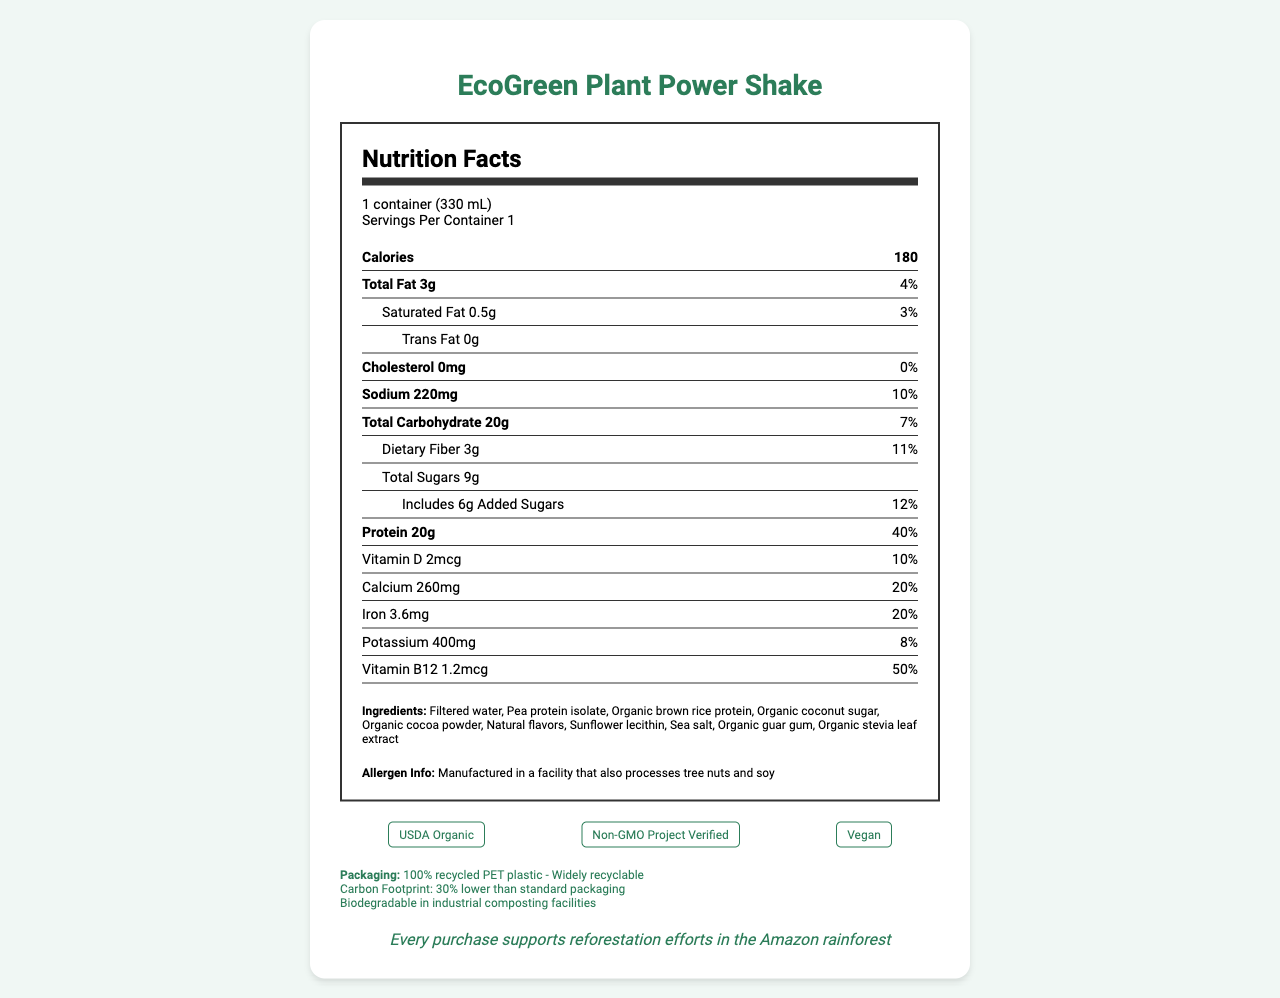what is the serving size of the product? The serving size is indicated at the top of the nutrition label, stating "1 container (330 mL)".
Answer: 1 container (330 mL) how many calories are in one serving of the EcoGreen Plant Power Shake? The calories per serving are listed directly under "Calories" with the number "180".
Answer: 180 what is the daily value percentage for protein per serving? The daily value percentage for the protein is given as "40%" next to "Protein 20g".
Answer: 40% what are the total carbohydrates in one serving? The amount of total carbohydrates is listed as "20g" next to "Total Carbohydrate".
Answer: 20g which certification is NOT listed on the document? A. USDA Organic B. Vegan C. Fair Trade D. Non-GMO Project Verified The listed certifications are "USDA Organic", "Non-GMO Project Verified", and "Vegan". "Fair Trade" is not mentioned.
Answer: C how much calcium is in one serving of the shake? The document lists "Calcium 260mg 20%" under the nutrition facts.
Answer: 260mg what is the carbon footprint reduction of the product’s packaging compared to standard packaging? The carbon footprint reduction is noted as "30% lower than standard packaging" under packaging information.
Answer: 30% lower does the product contain any cholesterol? The amount of cholesterol is listed as "0mg" with a daily value of "0%".
Answer: No can this product’s packaging be composted in a home composting environment? The packaging information specifies that it is "Biodegradable in industrial composting facilities", implying home composting is not feasible.
Answer: No how does the product contribute to conservation efforts? The conservation message at the bottom of the document states, "Every purchase supports reforestation efforts in the Amazon rainforest".
Answer: Every purchase supports reforestation efforts in the Amazon rainforest what is the continued website for the manufacturer of the product? The manufacturer's website is clearly listed as "www.greenlifenutrition.com".
Answer: www.greenlifenutrition.com which ingredient is NOT listed for this product? i. Filtered water ii. Pea protein isolate iii. Organic cane sugar iv. Organic stevia leaf extract The list of ingredients provided does not include "Organic cane sugar".
Answer: iii describe the primary features of the EcoGreen Plant Power Shake based on the document This summary captures the essential details about the product's nutritional info, eco-friendly packaging, and conservation efforts as presented in the document.
Answer: The EcoGreen Plant Power Shake is a USDA Organic, Non-GMO, and Vegan certified plant-based protein shake with 180 calories per serving. It contains 20g of protein, 20g of total carbohydrates, and 3g of total fat. The packaging is eco-friendly, made from 100% recycled PET plastic, widely recyclable, with a 30% lower carbon footprint than standard packaging and biodegradable in industrial composting facilities. The company supports reforestation efforts in the Amazon rainforest and ensures carbon-neutral shipping. what technological method is used for rendering the document? There is no information provided in the visual document about the technological method used for rendering it.
Answer: Not enough information 